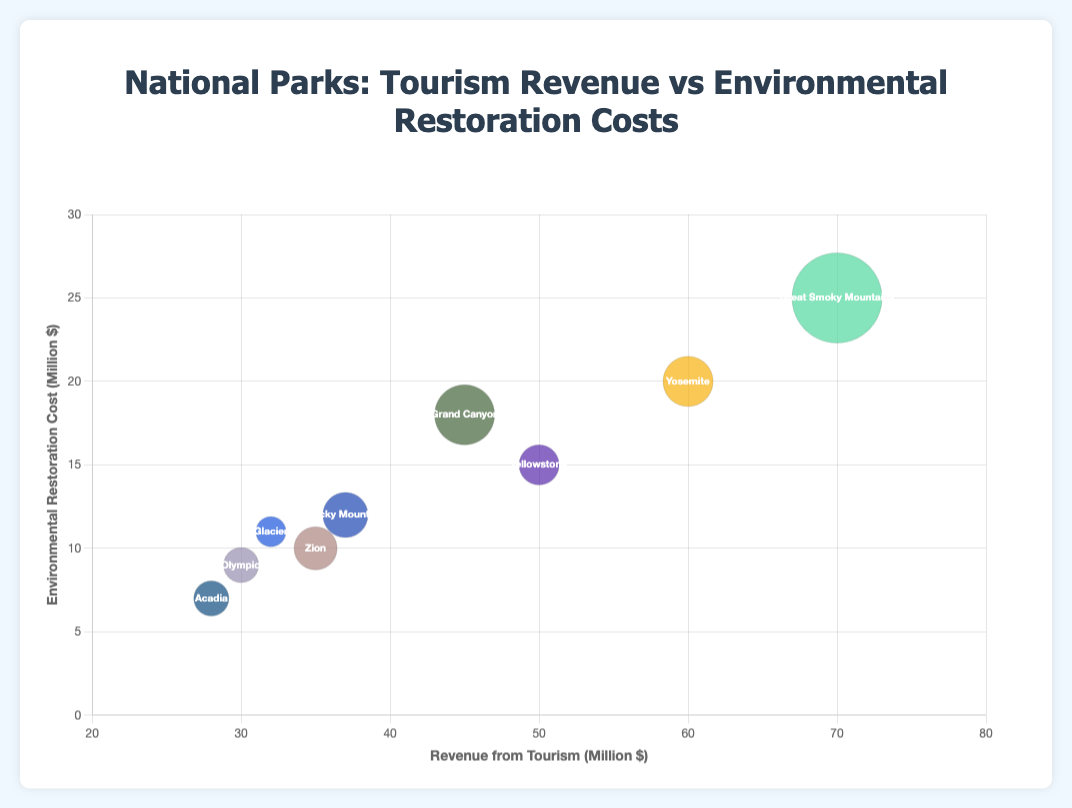What is the title of the figure? The title of the figure is usually found at the top of the chart. In this case, it is 'National Parks: Tourism Revenue vs Environmental Restoration Costs'.
Answer: National Parks: Tourism Revenue vs Environmental Restoration Costs Which national park has the highest revenue from tourism? By looking at the x-axis for the highest value, we see the bubble for Great Smoky Mountains National Park is the farthest to the right.
Answer: Great Smoky Mountains National Park What is the approximate restoration cost for Yellowstone National Park? Find the bubble labeled 'Yellowstone' and look at its position on the y-axis, which represents Environmental Restoration Cost. It is near 15 million dollars.
Answer: 15 million dollars Which national park has the smallest bubble, indicating the fewest number of visitors? The size of the bubble represents the number of visitors. The smallest bubble corresponds to Glacier National Park.
Answer: Glacier National Park How does the revenue from tourism for Yosemite National Park compare to Zion National Park? Compare their positions on the x-axis. Yosemite National Park is positioned at 60 million dollars, whereas Zion National Park is at 35 million dollars. Yosemite National Park has more revenue from tourism.
Answer: Yosemite National Park has more revenue from tourism What is the difference in environmental restoration costs between Great Smoky Mountains National Park and Olympic National Park? Locate the positions of these parks on the y-axis and subtract Olympic’s cost from Great Smoky Mountains' cost. Great Smoky Mountains is at 25 million dollars, and Olympic is at 9 million dollars. The difference is 25 - 9 = 16 million dollars.
Answer: 16 million dollars Which national park has the highest environmental restoration cost? Find the highest point on the y-axis, which corresponds to Great Smoky Mountains National Park.
Answer: Great Smoky Mountains National Park Which two parks have similar numbers of visitors? Look at the bubble sizes. Both Olympic National Park and Acadia National Park have similarly sized bubbles, indicating a comparable number of visitors.
Answer: Olympic National Park and Acadia National Park What is the total number of visitors for Yellowstone National Park and Rocky Mountain National Park? Add the number of visitors for both parks: 4,000,000 (Yellowstone) + 4,500,000 (Rocky Mountain) = 8,500,000.
Answer: 8.5 million visitors How does the environmental restoration cost of Grand Canyon National Park compare to Glacier National Park? By comparing their positions on the y-axis, Grand Canyon National Park has a higher restoration cost (18 million dollars) compared to Glacier (11 million dollars).
Answer: Grand Canyon National Park is higher than Glacier National Park 